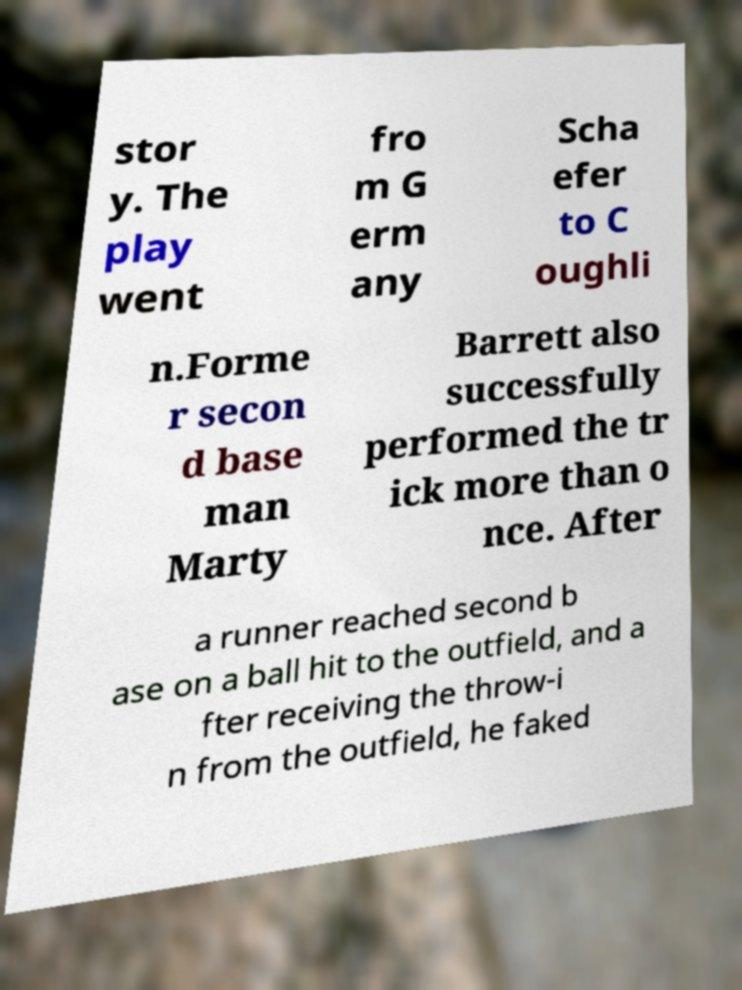Could you assist in decoding the text presented in this image and type it out clearly? stor y. The play went fro m G erm any Scha efer to C oughli n.Forme r secon d base man Marty Barrett also successfully performed the tr ick more than o nce. After a runner reached second b ase on a ball hit to the outfield, and a fter receiving the throw-i n from the outfield, he faked 